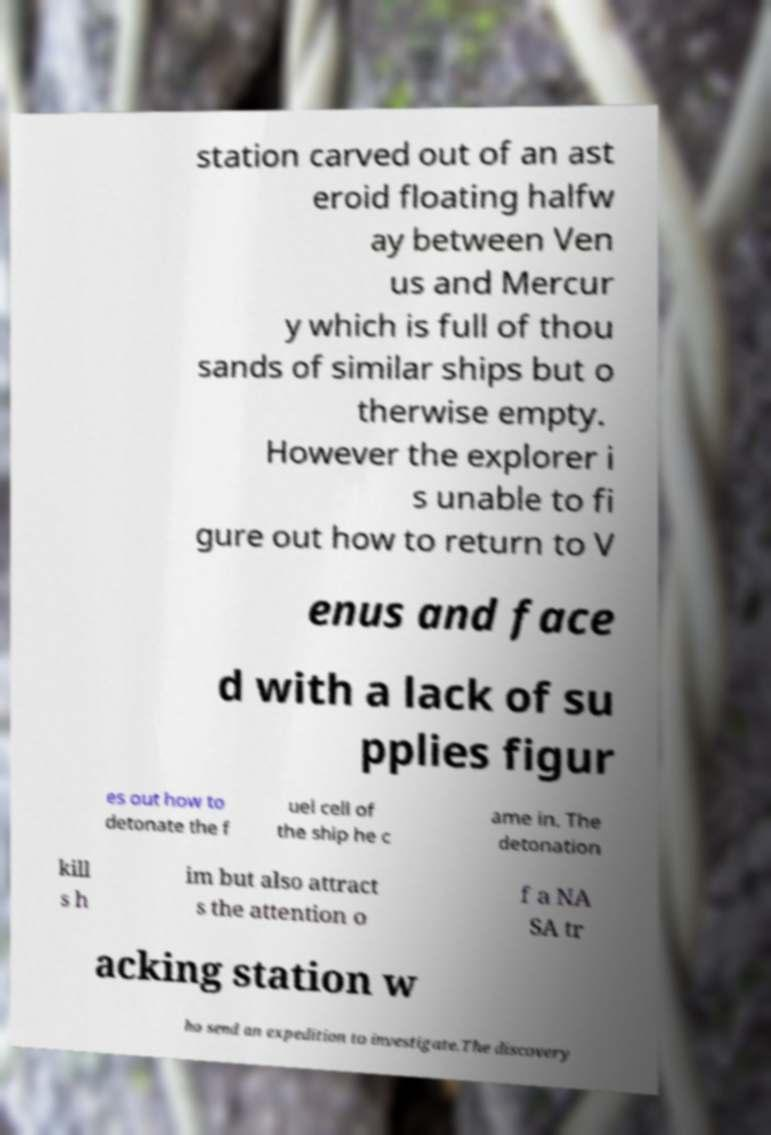For documentation purposes, I need the text within this image transcribed. Could you provide that? station carved out of an ast eroid floating halfw ay between Ven us and Mercur y which is full of thou sands of similar ships but o therwise empty. However the explorer i s unable to fi gure out how to return to V enus and face d with a lack of su pplies figur es out how to detonate the f uel cell of the ship he c ame in. The detonation kill s h im but also attract s the attention o f a NA SA tr acking station w ho send an expedition to investigate.The discovery 